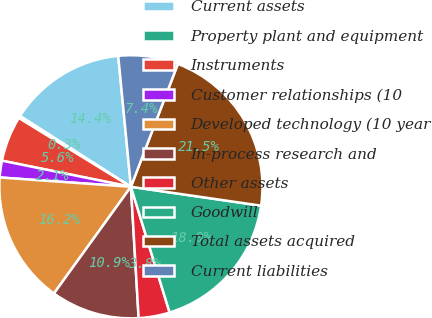Convert chart. <chart><loc_0><loc_0><loc_500><loc_500><pie_chart><fcel>Current assets<fcel>Property plant and equipment<fcel>Instruments<fcel>Customer relationships (10<fcel>Developed technology (10 year<fcel>In-process research and<fcel>Other assets<fcel>Goodwill<fcel>Total assets acquired<fcel>Current liabilities<nl><fcel>14.42%<fcel>0.28%<fcel>5.58%<fcel>2.05%<fcel>16.18%<fcel>10.88%<fcel>3.82%<fcel>17.95%<fcel>21.48%<fcel>7.35%<nl></chart> 